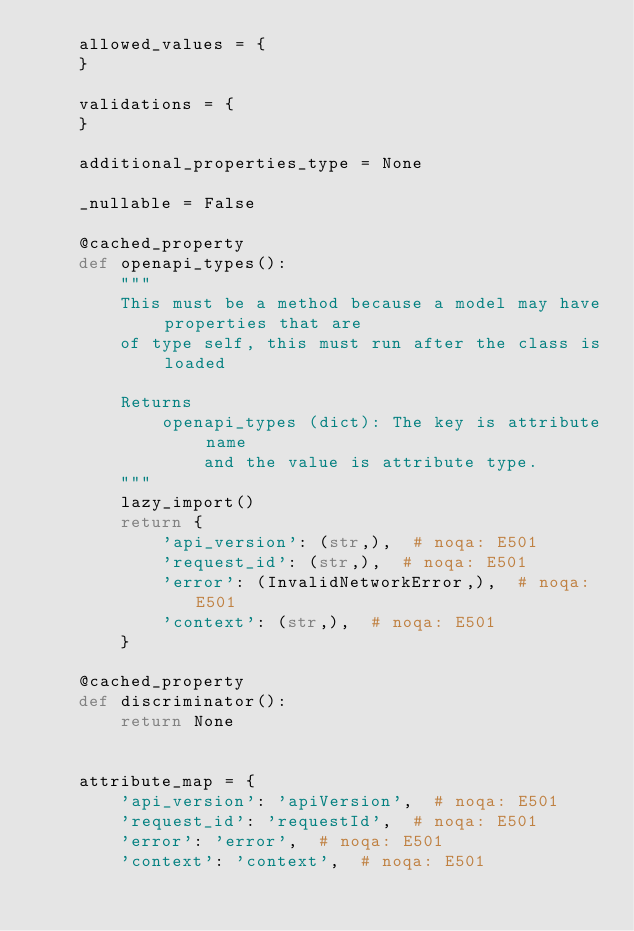<code> <loc_0><loc_0><loc_500><loc_500><_Python_>    allowed_values = {
    }

    validations = {
    }

    additional_properties_type = None

    _nullable = False

    @cached_property
    def openapi_types():
        """
        This must be a method because a model may have properties that are
        of type self, this must run after the class is loaded

        Returns
            openapi_types (dict): The key is attribute name
                and the value is attribute type.
        """
        lazy_import()
        return {
            'api_version': (str,),  # noqa: E501
            'request_id': (str,),  # noqa: E501
            'error': (InvalidNetworkError,),  # noqa: E501
            'context': (str,),  # noqa: E501
        }

    @cached_property
    def discriminator():
        return None


    attribute_map = {
        'api_version': 'apiVersion',  # noqa: E501
        'request_id': 'requestId',  # noqa: E501
        'error': 'error',  # noqa: E501
        'context': 'context',  # noqa: E501</code> 